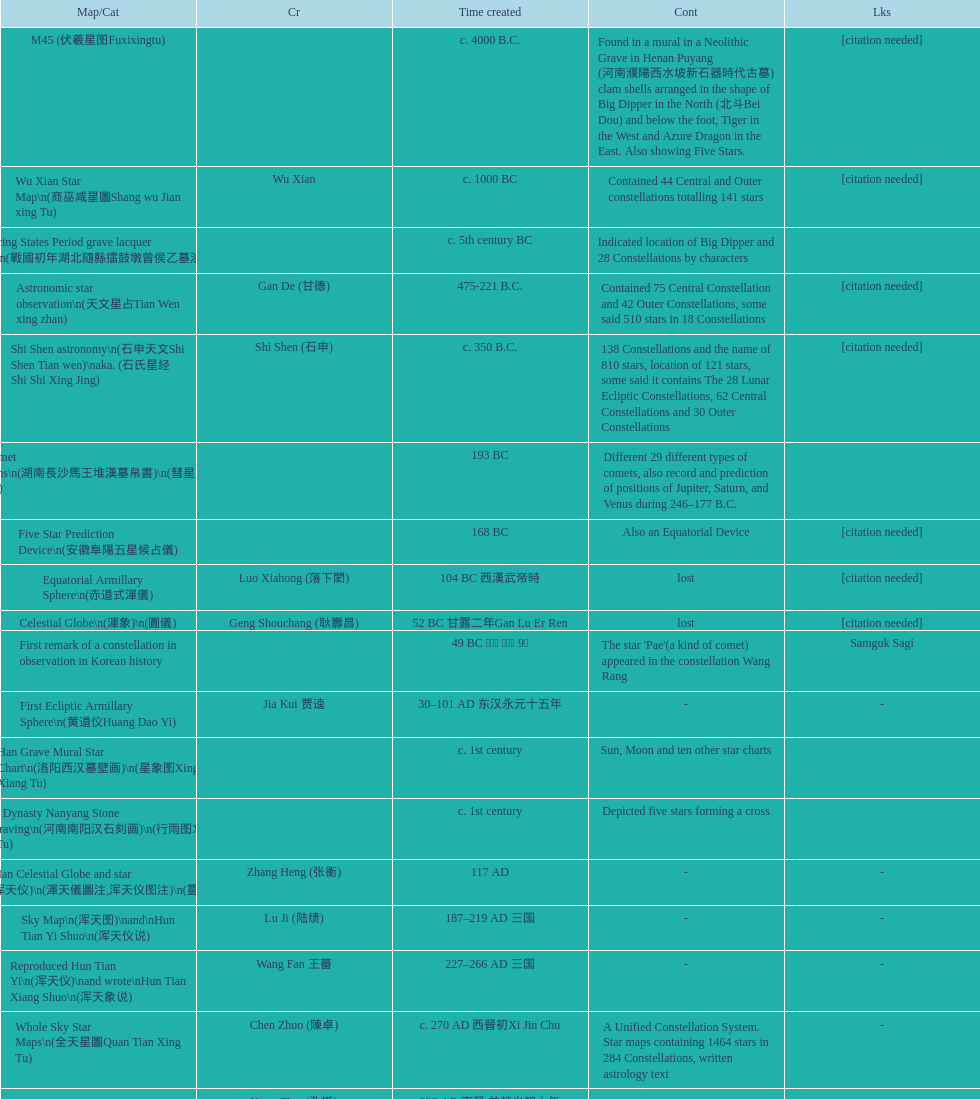Which star map was created earlier, celestial globe or the han grave mural star chart? Celestial Globe. 